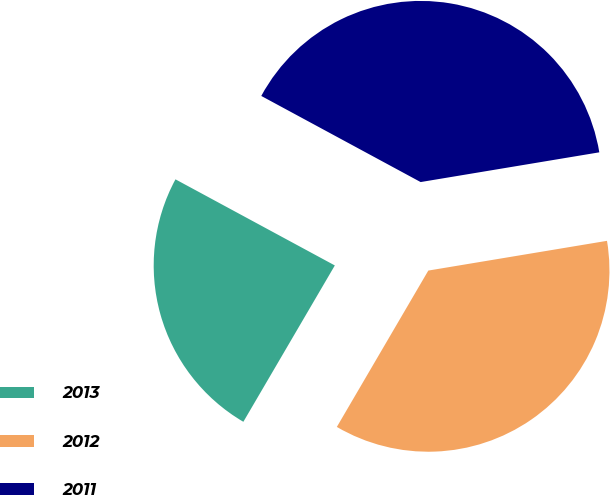Convert chart. <chart><loc_0><loc_0><loc_500><loc_500><pie_chart><fcel>2013<fcel>2012<fcel>2011<nl><fcel>24.46%<fcel>36.05%<fcel>39.49%<nl></chart> 